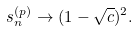Convert formula to latex. <formula><loc_0><loc_0><loc_500><loc_500>s _ { n } ^ { ( p ) } \to ( 1 - \sqrt { c } ) ^ { 2 } .</formula> 